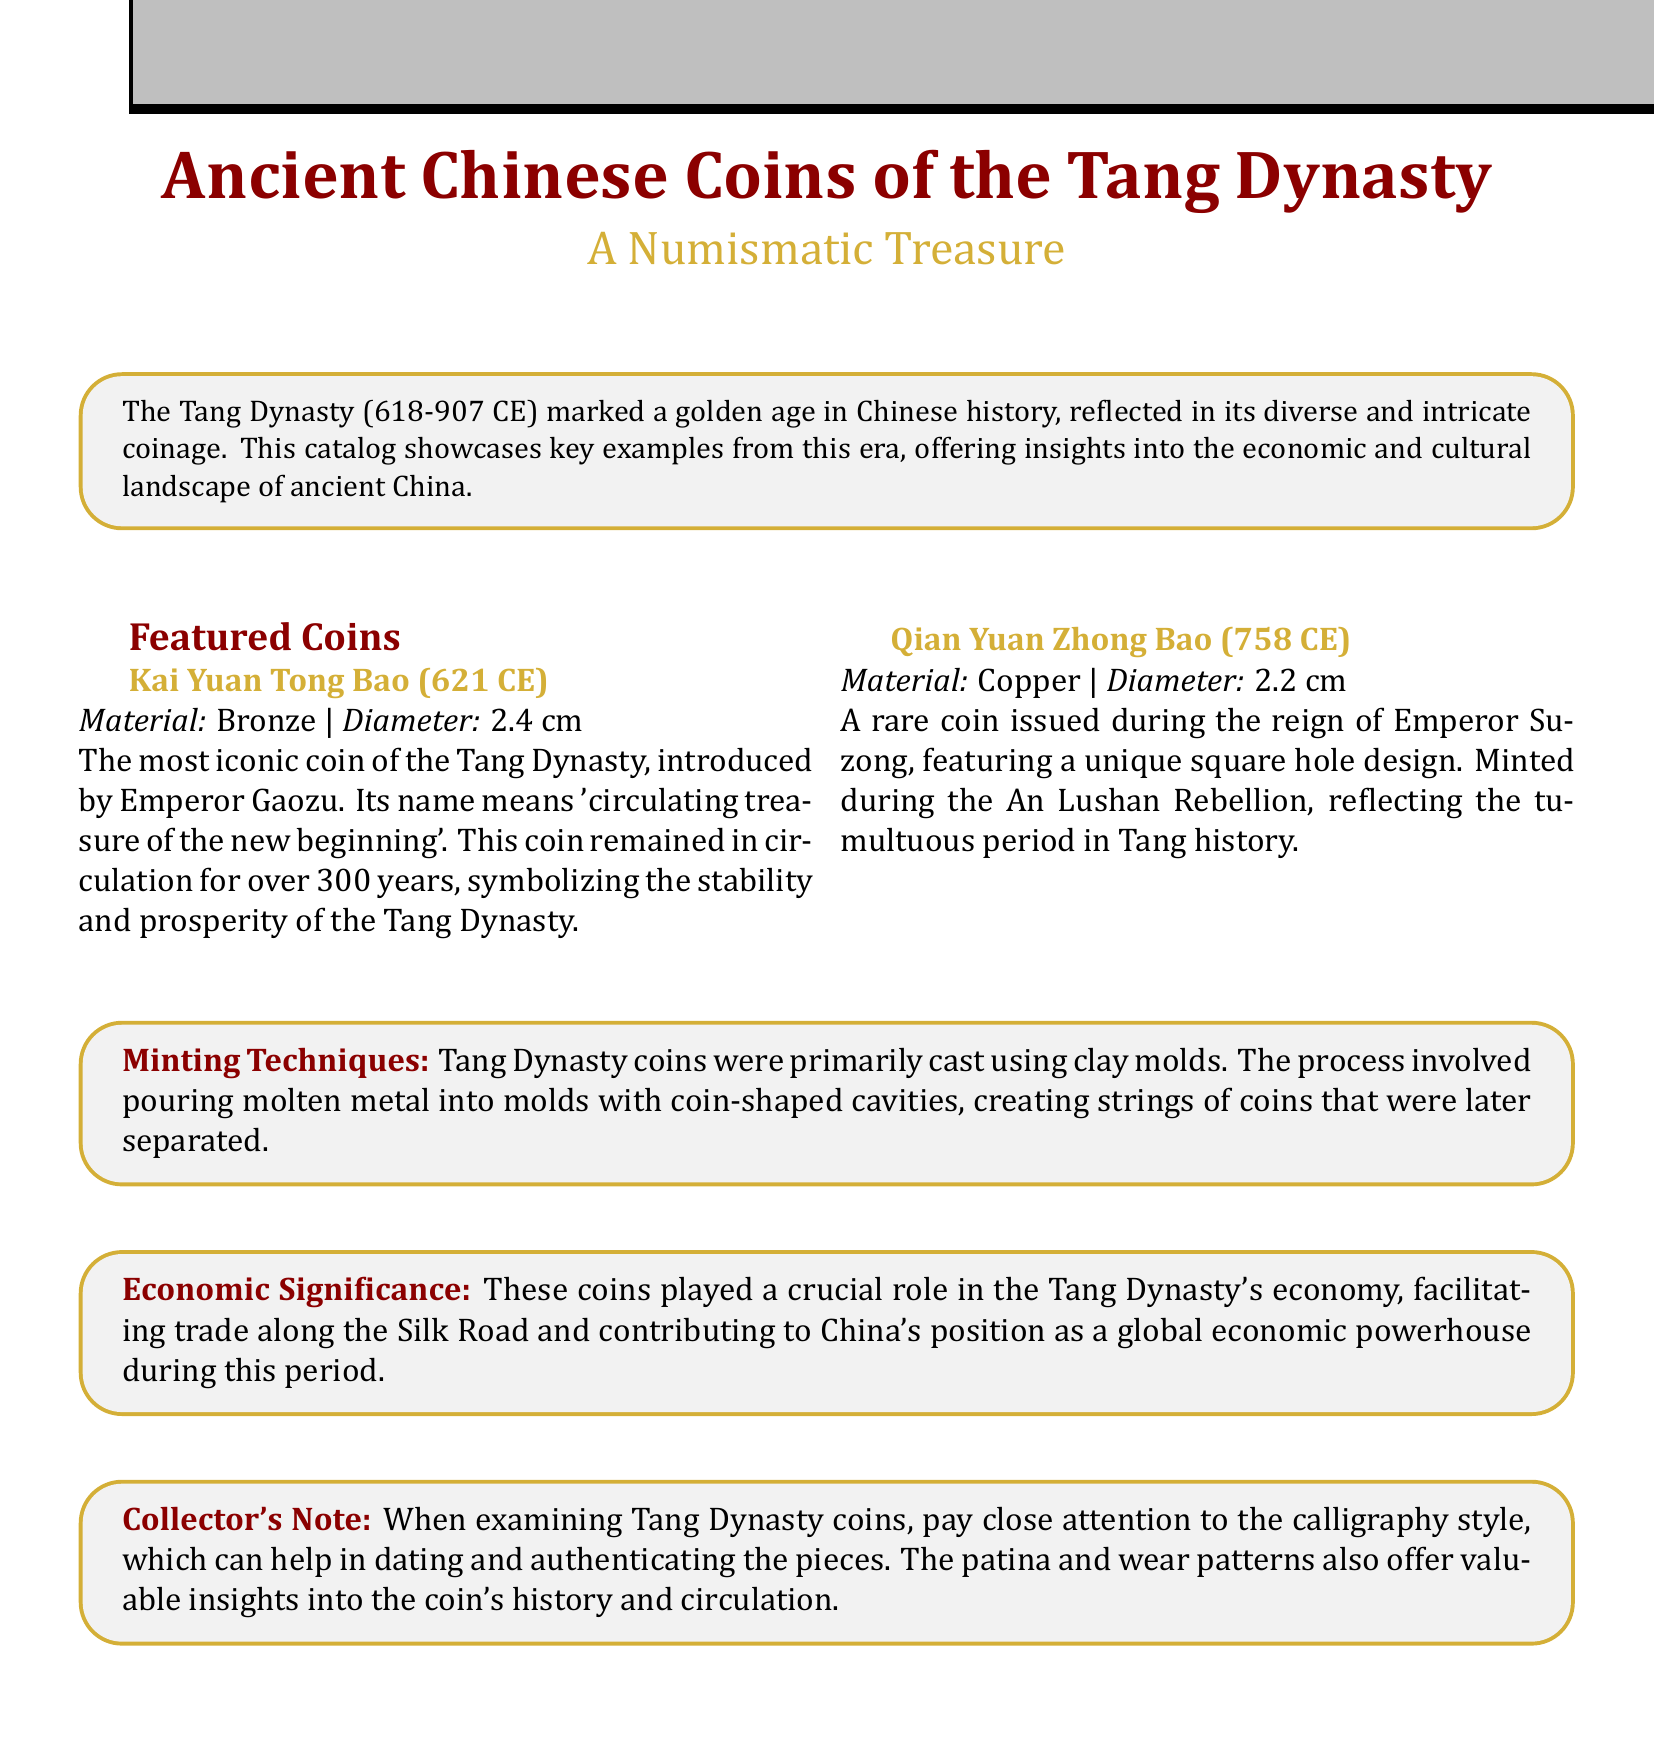What is the time period of the Tang Dynasty? The Tang Dynasty lasted from 618 to 907 CE, as stated in the catalog introduction.
Answer: 618-907 CE What is the diameter of the Kai Yuan Tong Bao coin? The catalog specifies the diameter of the Kai Yuan Tong Bao coin as 2.4 cm.
Answer: 2.4 cm Who introduced the Kai Yuan Tong Bao? The catalog mentions that the Kai Yuan Tong Bao was introduced by Emperor Gaozu.
Answer: Emperor Gaozu Which coin was minted during the An Lushan Rebellion? The Qian Yuan Zhong Bao coin, as indicated in the document, was minted during the An Lushan Rebellion.
Answer: Qian Yuan Zhong Bao What material is the Qian Yuan Zhong Bao made of? The document specifies that the Qian Yuan Zhong Bao is made of copper.
Answer: Copper What type of minting technique was used for Tang Dynasty coins? The document states that Tang Dynasty coins were cast using clay molds.
Answer: Clay molds What does the name "Kai Yuan Tong Bao" mean? In the catalog, it is explained that "Kai Yuan Tong Bao" means 'circulating treasure of the new beginning'.
Answer: Circulating treasure of the new beginning What is a key role of Tang Dynasty coins in the economy? The document states that these coins facilitated trade along the Silk Road.
Answer: Facilitating trade along the Silk Road What should collectors pay attention to when examining Tang Dynasty coins? The catalog advises collectors to focus on the calligraphy style for dating and authenticity.
Answer: Calligraphy style 